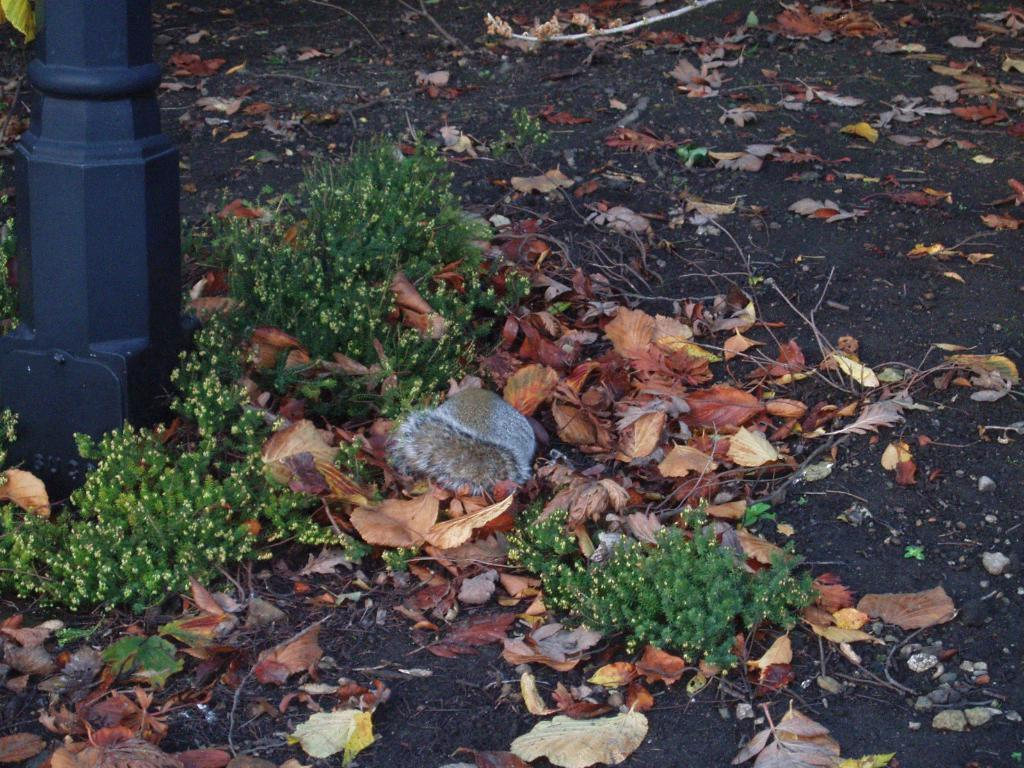What type of living organisms can be seen in the image? Plants can be seen in the image. What is the tall, vertical object in the image? There is a pole in the image. What is present at the bottom of the image? Dried leaves are present at the bottom of the image. Can you describe the other object on the surface in the image? Unfortunately, the facts provided do not give enough information to describe the other object on the surface in the image. How many firemen are visible in the image? There are no firemen present in the image. What type of houses can be seen in the background of the image? There is no background or houses mentioned in the provided facts, so we cannot answer this question. 